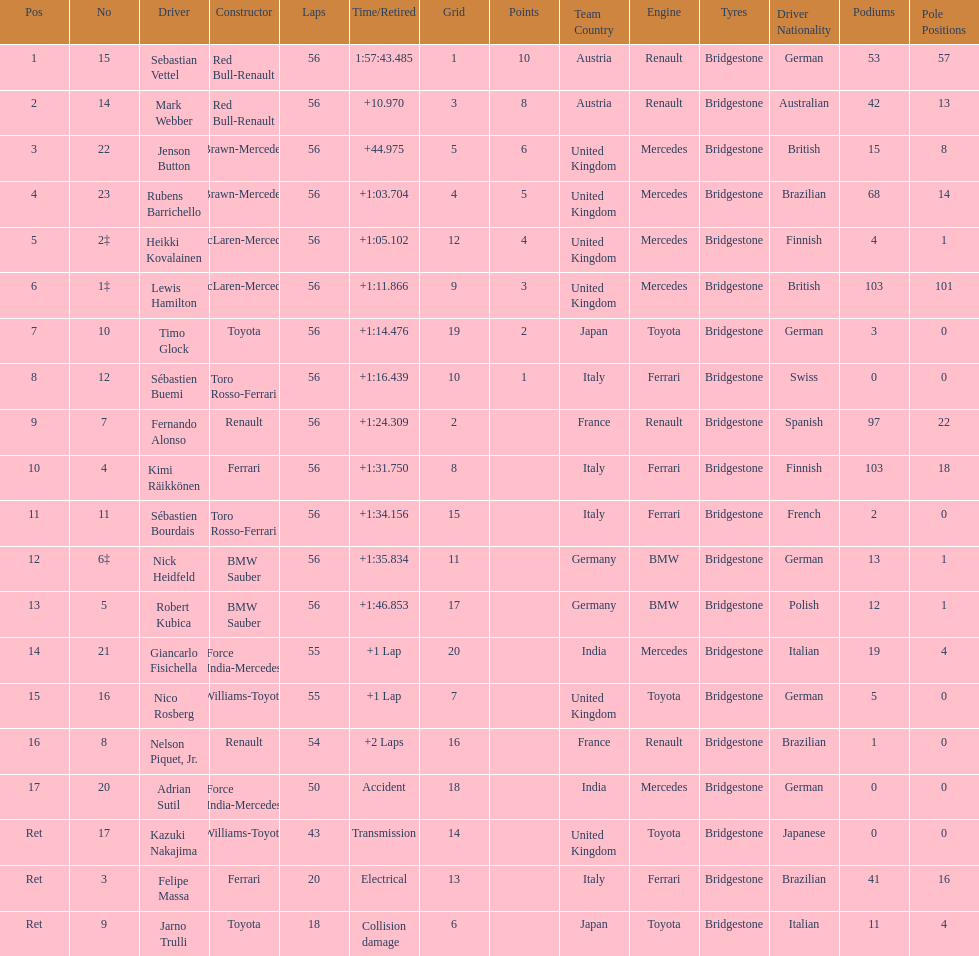What name is just previous to kazuki nakjima on the list? Adrian Sutil. 